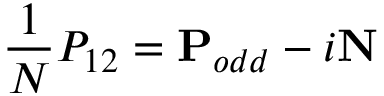Convert formula to latex. <formula><loc_0><loc_0><loc_500><loc_500>\frac { 1 } { N } P _ { 1 2 } = P _ { o d d } - i N</formula> 